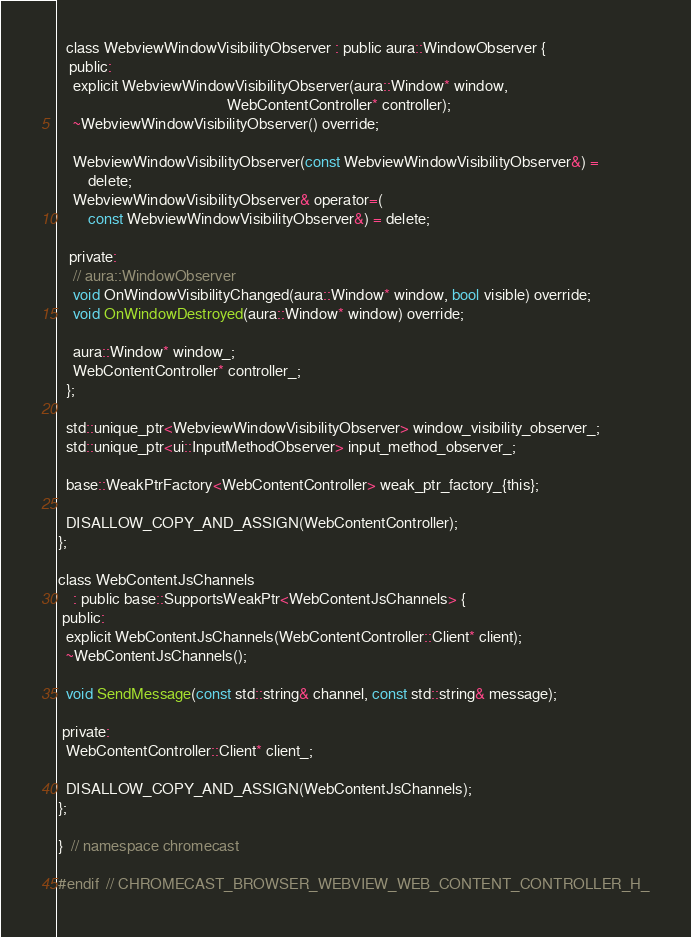<code> <loc_0><loc_0><loc_500><loc_500><_C_>  class WebviewWindowVisibilityObserver : public aura::WindowObserver {
   public:
    explicit WebviewWindowVisibilityObserver(aura::Window* window,
                                             WebContentController* controller);
    ~WebviewWindowVisibilityObserver() override;

    WebviewWindowVisibilityObserver(const WebviewWindowVisibilityObserver&) =
        delete;
    WebviewWindowVisibilityObserver& operator=(
        const WebviewWindowVisibilityObserver&) = delete;

   private:
    // aura::WindowObserver
    void OnWindowVisibilityChanged(aura::Window* window, bool visible) override;
    void OnWindowDestroyed(aura::Window* window) override;

    aura::Window* window_;
    WebContentController* controller_;
  };

  std::unique_ptr<WebviewWindowVisibilityObserver> window_visibility_observer_;
  std::unique_ptr<ui::InputMethodObserver> input_method_observer_;

  base::WeakPtrFactory<WebContentController> weak_ptr_factory_{this};

  DISALLOW_COPY_AND_ASSIGN(WebContentController);
};

class WebContentJsChannels
    : public base::SupportsWeakPtr<WebContentJsChannels> {
 public:
  explicit WebContentJsChannels(WebContentController::Client* client);
  ~WebContentJsChannels();

  void SendMessage(const std::string& channel, const std::string& message);

 private:
  WebContentController::Client* client_;

  DISALLOW_COPY_AND_ASSIGN(WebContentJsChannels);
};

}  // namespace chromecast

#endif  // CHROMECAST_BROWSER_WEBVIEW_WEB_CONTENT_CONTROLLER_H_
</code> 